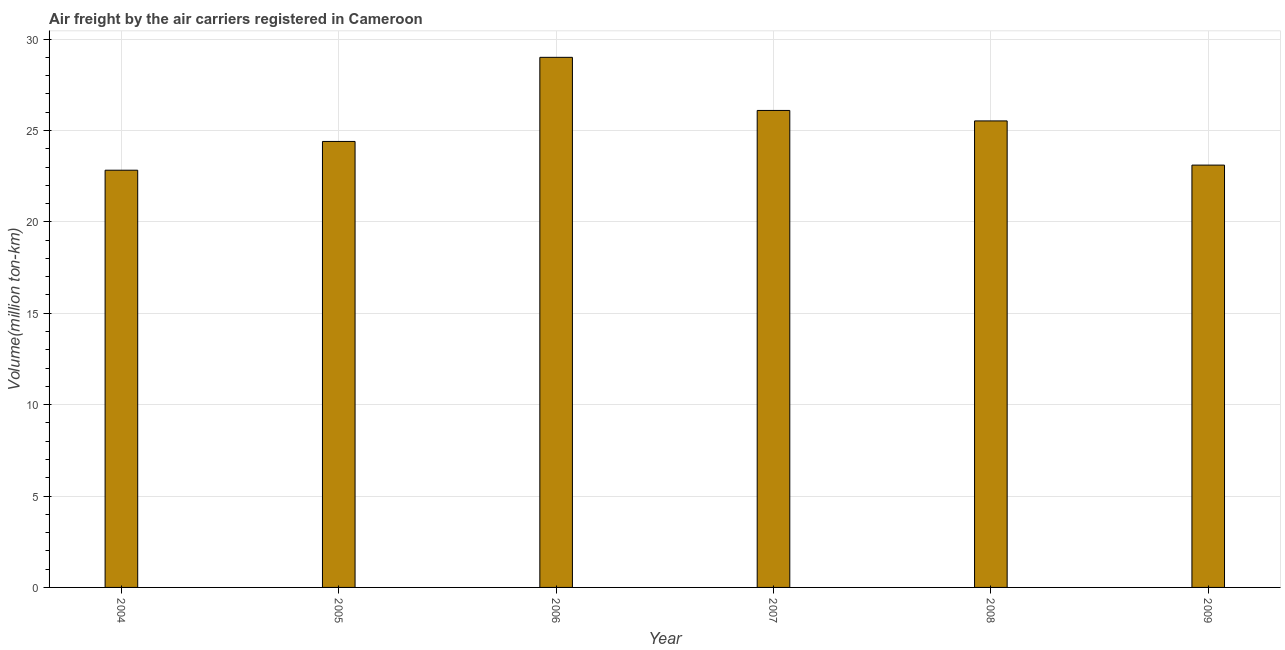What is the title of the graph?
Your response must be concise. Air freight by the air carriers registered in Cameroon. What is the label or title of the X-axis?
Provide a succinct answer. Year. What is the label or title of the Y-axis?
Your answer should be compact. Volume(million ton-km). What is the air freight in 2009?
Provide a short and direct response. 23.11. Across all years, what is the maximum air freight?
Your response must be concise. 29. Across all years, what is the minimum air freight?
Your response must be concise. 22.82. In which year was the air freight maximum?
Keep it short and to the point. 2006. What is the sum of the air freight?
Offer a very short reply. 150.95. What is the difference between the air freight in 2004 and 2009?
Ensure brevity in your answer.  -0.28. What is the average air freight per year?
Make the answer very short. 25.16. What is the median air freight?
Provide a short and direct response. 24.96. What is the ratio of the air freight in 2004 to that in 2006?
Give a very brief answer. 0.79. Is the air freight in 2005 less than that in 2006?
Offer a terse response. Yes. Is the difference between the air freight in 2006 and 2007 greater than the difference between any two years?
Give a very brief answer. No. What is the difference between the highest and the second highest air freight?
Your answer should be very brief. 2.91. Is the sum of the air freight in 2006 and 2008 greater than the maximum air freight across all years?
Give a very brief answer. Yes. What is the difference between the highest and the lowest air freight?
Keep it short and to the point. 6.18. How many bars are there?
Ensure brevity in your answer.  6. Are all the bars in the graph horizontal?
Offer a very short reply. No. What is the difference between two consecutive major ticks on the Y-axis?
Provide a short and direct response. 5. Are the values on the major ticks of Y-axis written in scientific E-notation?
Give a very brief answer. No. What is the Volume(million ton-km) of 2004?
Your response must be concise. 22.82. What is the Volume(million ton-km) in 2005?
Your response must be concise. 24.4. What is the Volume(million ton-km) of 2006?
Your answer should be very brief. 29. What is the Volume(million ton-km) in 2007?
Your answer should be compact. 26.09. What is the Volume(million ton-km) in 2008?
Give a very brief answer. 25.52. What is the Volume(million ton-km) in 2009?
Ensure brevity in your answer.  23.11. What is the difference between the Volume(million ton-km) in 2004 and 2005?
Offer a terse response. -1.57. What is the difference between the Volume(million ton-km) in 2004 and 2006?
Make the answer very short. -6.18. What is the difference between the Volume(million ton-km) in 2004 and 2007?
Make the answer very short. -3.27. What is the difference between the Volume(million ton-km) in 2004 and 2008?
Keep it short and to the point. -2.7. What is the difference between the Volume(million ton-km) in 2004 and 2009?
Make the answer very short. -0.28. What is the difference between the Volume(million ton-km) in 2005 and 2006?
Keep it short and to the point. -4.6. What is the difference between the Volume(million ton-km) in 2005 and 2007?
Provide a short and direct response. -1.7. What is the difference between the Volume(million ton-km) in 2005 and 2008?
Make the answer very short. -1.12. What is the difference between the Volume(million ton-km) in 2005 and 2009?
Your answer should be very brief. 1.29. What is the difference between the Volume(million ton-km) in 2006 and 2007?
Offer a terse response. 2.91. What is the difference between the Volume(million ton-km) in 2006 and 2008?
Ensure brevity in your answer.  3.48. What is the difference between the Volume(million ton-km) in 2006 and 2009?
Ensure brevity in your answer.  5.9. What is the difference between the Volume(million ton-km) in 2007 and 2008?
Your answer should be very brief. 0.57. What is the difference between the Volume(million ton-km) in 2007 and 2009?
Give a very brief answer. 2.99. What is the difference between the Volume(million ton-km) in 2008 and 2009?
Your response must be concise. 2.42. What is the ratio of the Volume(million ton-km) in 2004 to that in 2005?
Offer a very short reply. 0.94. What is the ratio of the Volume(million ton-km) in 2004 to that in 2006?
Your response must be concise. 0.79. What is the ratio of the Volume(million ton-km) in 2004 to that in 2007?
Give a very brief answer. 0.88. What is the ratio of the Volume(million ton-km) in 2004 to that in 2008?
Offer a terse response. 0.89. What is the ratio of the Volume(million ton-km) in 2004 to that in 2009?
Provide a succinct answer. 0.99. What is the ratio of the Volume(million ton-km) in 2005 to that in 2006?
Offer a terse response. 0.84. What is the ratio of the Volume(million ton-km) in 2005 to that in 2007?
Keep it short and to the point. 0.94. What is the ratio of the Volume(million ton-km) in 2005 to that in 2008?
Offer a terse response. 0.96. What is the ratio of the Volume(million ton-km) in 2005 to that in 2009?
Offer a very short reply. 1.06. What is the ratio of the Volume(million ton-km) in 2006 to that in 2007?
Keep it short and to the point. 1.11. What is the ratio of the Volume(million ton-km) in 2006 to that in 2008?
Offer a very short reply. 1.14. What is the ratio of the Volume(million ton-km) in 2006 to that in 2009?
Offer a terse response. 1.25. What is the ratio of the Volume(million ton-km) in 2007 to that in 2009?
Ensure brevity in your answer.  1.13. What is the ratio of the Volume(million ton-km) in 2008 to that in 2009?
Offer a terse response. 1.1. 